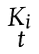Convert formula to latex. <formula><loc_0><loc_0><loc_500><loc_500>\begin{smallmatrix} { K _ { i } } \\ { t } \end{smallmatrix}</formula> 